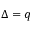<formula> <loc_0><loc_0><loc_500><loc_500>\Delta = q</formula> 